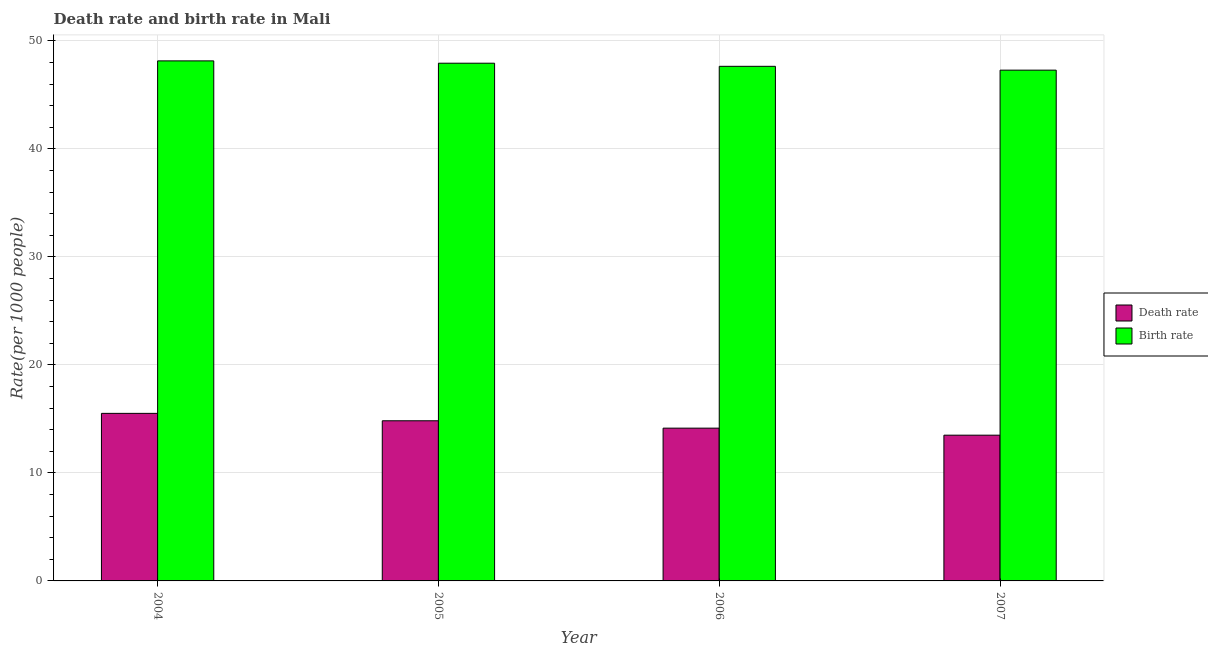How many groups of bars are there?
Your response must be concise. 4. Are the number of bars per tick equal to the number of legend labels?
Offer a terse response. Yes. How many bars are there on the 4th tick from the left?
Keep it short and to the point. 2. What is the birth rate in 2006?
Provide a short and direct response. 47.64. Across all years, what is the maximum death rate?
Your answer should be very brief. 15.51. Across all years, what is the minimum death rate?
Keep it short and to the point. 13.49. In which year was the birth rate maximum?
Offer a very short reply. 2004. What is the total death rate in the graph?
Your answer should be compact. 57.98. What is the difference between the death rate in 2004 and that in 2007?
Keep it short and to the point. 2.02. What is the difference between the birth rate in 2006 and the death rate in 2007?
Offer a terse response. 0.35. What is the average birth rate per year?
Provide a succinct answer. 47.75. In the year 2006, what is the difference between the birth rate and death rate?
Keep it short and to the point. 0. What is the ratio of the death rate in 2005 to that in 2006?
Give a very brief answer. 1.05. Is the death rate in 2005 less than that in 2006?
Your response must be concise. No. Is the difference between the birth rate in 2004 and 2006 greater than the difference between the death rate in 2004 and 2006?
Your answer should be compact. No. What is the difference between the highest and the second highest death rate?
Ensure brevity in your answer.  0.69. What is the difference between the highest and the lowest birth rate?
Your response must be concise. 0.86. In how many years, is the death rate greater than the average death rate taken over all years?
Provide a short and direct response. 2. Is the sum of the death rate in 2006 and 2007 greater than the maximum birth rate across all years?
Keep it short and to the point. Yes. What does the 1st bar from the left in 2007 represents?
Ensure brevity in your answer.  Death rate. What does the 2nd bar from the right in 2005 represents?
Offer a terse response. Death rate. How many bars are there?
Give a very brief answer. 8. Are all the bars in the graph horizontal?
Provide a short and direct response. No. What is the difference between two consecutive major ticks on the Y-axis?
Your response must be concise. 10. Are the values on the major ticks of Y-axis written in scientific E-notation?
Your response must be concise. No. Does the graph contain any zero values?
Give a very brief answer. No. Where does the legend appear in the graph?
Offer a very short reply. Center right. How many legend labels are there?
Ensure brevity in your answer.  2. How are the legend labels stacked?
Offer a terse response. Vertical. What is the title of the graph?
Make the answer very short. Death rate and birth rate in Mali. What is the label or title of the Y-axis?
Make the answer very short. Rate(per 1000 people). What is the Rate(per 1000 people) in Death rate in 2004?
Offer a very short reply. 15.51. What is the Rate(per 1000 people) in Birth rate in 2004?
Ensure brevity in your answer.  48.15. What is the Rate(per 1000 people) in Death rate in 2005?
Offer a very short reply. 14.83. What is the Rate(per 1000 people) in Birth rate in 2005?
Keep it short and to the point. 47.93. What is the Rate(per 1000 people) of Death rate in 2006?
Your answer should be compact. 14.14. What is the Rate(per 1000 people) of Birth rate in 2006?
Your response must be concise. 47.64. What is the Rate(per 1000 people) in Death rate in 2007?
Your answer should be compact. 13.49. What is the Rate(per 1000 people) in Birth rate in 2007?
Your answer should be very brief. 47.29. Across all years, what is the maximum Rate(per 1000 people) in Death rate?
Give a very brief answer. 15.51. Across all years, what is the maximum Rate(per 1000 people) of Birth rate?
Your answer should be very brief. 48.15. Across all years, what is the minimum Rate(per 1000 people) of Death rate?
Ensure brevity in your answer.  13.49. Across all years, what is the minimum Rate(per 1000 people) of Birth rate?
Keep it short and to the point. 47.29. What is the total Rate(per 1000 people) of Death rate in the graph?
Your response must be concise. 57.98. What is the total Rate(per 1000 people) in Birth rate in the graph?
Keep it short and to the point. 191. What is the difference between the Rate(per 1000 people) of Death rate in 2004 and that in 2005?
Your answer should be very brief. 0.69. What is the difference between the Rate(per 1000 people) of Birth rate in 2004 and that in 2005?
Keep it short and to the point. 0.22. What is the difference between the Rate(per 1000 people) in Death rate in 2004 and that in 2006?
Your response must be concise. 1.37. What is the difference between the Rate(per 1000 people) in Birth rate in 2004 and that in 2006?
Provide a short and direct response. 0.5. What is the difference between the Rate(per 1000 people) of Death rate in 2004 and that in 2007?
Your answer should be compact. 2.02. What is the difference between the Rate(per 1000 people) of Birth rate in 2004 and that in 2007?
Offer a very short reply. 0.86. What is the difference between the Rate(per 1000 people) of Death rate in 2005 and that in 2006?
Your response must be concise. 0.68. What is the difference between the Rate(per 1000 people) of Birth rate in 2005 and that in 2006?
Offer a terse response. 0.29. What is the difference between the Rate(per 1000 people) of Death rate in 2005 and that in 2007?
Provide a short and direct response. 1.33. What is the difference between the Rate(per 1000 people) in Birth rate in 2005 and that in 2007?
Your answer should be compact. 0.64. What is the difference between the Rate(per 1000 people) of Death rate in 2006 and that in 2007?
Make the answer very short. 0.65. What is the difference between the Rate(per 1000 people) in Birth rate in 2006 and that in 2007?
Provide a succinct answer. 0.35. What is the difference between the Rate(per 1000 people) of Death rate in 2004 and the Rate(per 1000 people) of Birth rate in 2005?
Provide a succinct answer. -32.42. What is the difference between the Rate(per 1000 people) of Death rate in 2004 and the Rate(per 1000 people) of Birth rate in 2006?
Provide a succinct answer. -32.13. What is the difference between the Rate(per 1000 people) of Death rate in 2004 and the Rate(per 1000 people) of Birth rate in 2007?
Provide a succinct answer. -31.77. What is the difference between the Rate(per 1000 people) in Death rate in 2005 and the Rate(per 1000 people) in Birth rate in 2006?
Make the answer very short. -32.81. What is the difference between the Rate(per 1000 people) of Death rate in 2005 and the Rate(per 1000 people) of Birth rate in 2007?
Your response must be concise. -32.46. What is the difference between the Rate(per 1000 people) in Death rate in 2006 and the Rate(per 1000 people) in Birth rate in 2007?
Ensure brevity in your answer.  -33.14. What is the average Rate(per 1000 people) in Death rate per year?
Make the answer very short. 14.49. What is the average Rate(per 1000 people) in Birth rate per year?
Offer a terse response. 47.75. In the year 2004, what is the difference between the Rate(per 1000 people) in Death rate and Rate(per 1000 people) in Birth rate?
Give a very brief answer. -32.63. In the year 2005, what is the difference between the Rate(per 1000 people) in Death rate and Rate(per 1000 people) in Birth rate?
Ensure brevity in your answer.  -33.1. In the year 2006, what is the difference between the Rate(per 1000 people) of Death rate and Rate(per 1000 people) of Birth rate?
Provide a short and direct response. -33.5. In the year 2007, what is the difference between the Rate(per 1000 people) in Death rate and Rate(per 1000 people) in Birth rate?
Offer a terse response. -33.79. What is the ratio of the Rate(per 1000 people) in Death rate in 2004 to that in 2005?
Provide a succinct answer. 1.05. What is the ratio of the Rate(per 1000 people) in Death rate in 2004 to that in 2006?
Give a very brief answer. 1.1. What is the ratio of the Rate(per 1000 people) in Birth rate in 2004 to that in 2006?
Your answer should be very brief. 1.01. What is the ratio of the Rate(per 1000 people) in Death rate in 2004 to that in 2007?
Your answer should be very brief. 1.15. What is the ratio of the Rate(per 1000 people) of Birth rate in 2004 to that in 2007?
Your answer should be very brief. 1.02. What is the ratio of the Rate(per 1000 people) of Death rate in 2005 to that in 2006?
Offer a terse response. 1.05. What is the ratio of the Rate(per 1000 people) of Birth rate in 2005 to that in 2006?
Your response must be concise. 1.01. What is the ratio of the Rate(per 1000 people) in Death rate in 2005 to that in 2007?
Offer a terse response. 1.1. What is the ratio of the Rate(per 1000 people) of Birth rate in 2005 to that in 2007?
Provide a succinct answer. 1.01. What is the ratio of the Rate(per 1000 people) in Death rate in 2006 to that in 2007?
Offer a very short reply. 1.05. What is the ratio of the Rate(per 1000 people) in Birth rate in 2006 to that in 2007?
Keep it short and to the point. 1.01. What is the difference between the highest and the second highest Rate(per 1000 people) in Death rate?
Provide a short and direct response. 0.69. What is the difference between the highest and the second highest Rate(per 1000 people) in Birth rate?
Ensure brevity in your answer.  0.22. What is the difference between the highest and the lowest Rate(per 1000 people) in Death rate?
Your answer should be very brief. 2.02. What is the difference between the highest and the lowest Rate(per 1000 people) in Birth rate?
Offer a terse response. 0.86. 